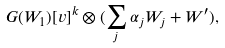Convert formula to latex. <formula><loc_0><loc_0><loc_500><loc_500>G ( W _ { 1 } ) [ v ] ^ { k } \otimes ( \sum _ { j } \alpha _ { j } W _ { j } + { W } ^ { \prime } ) ,</formula> 